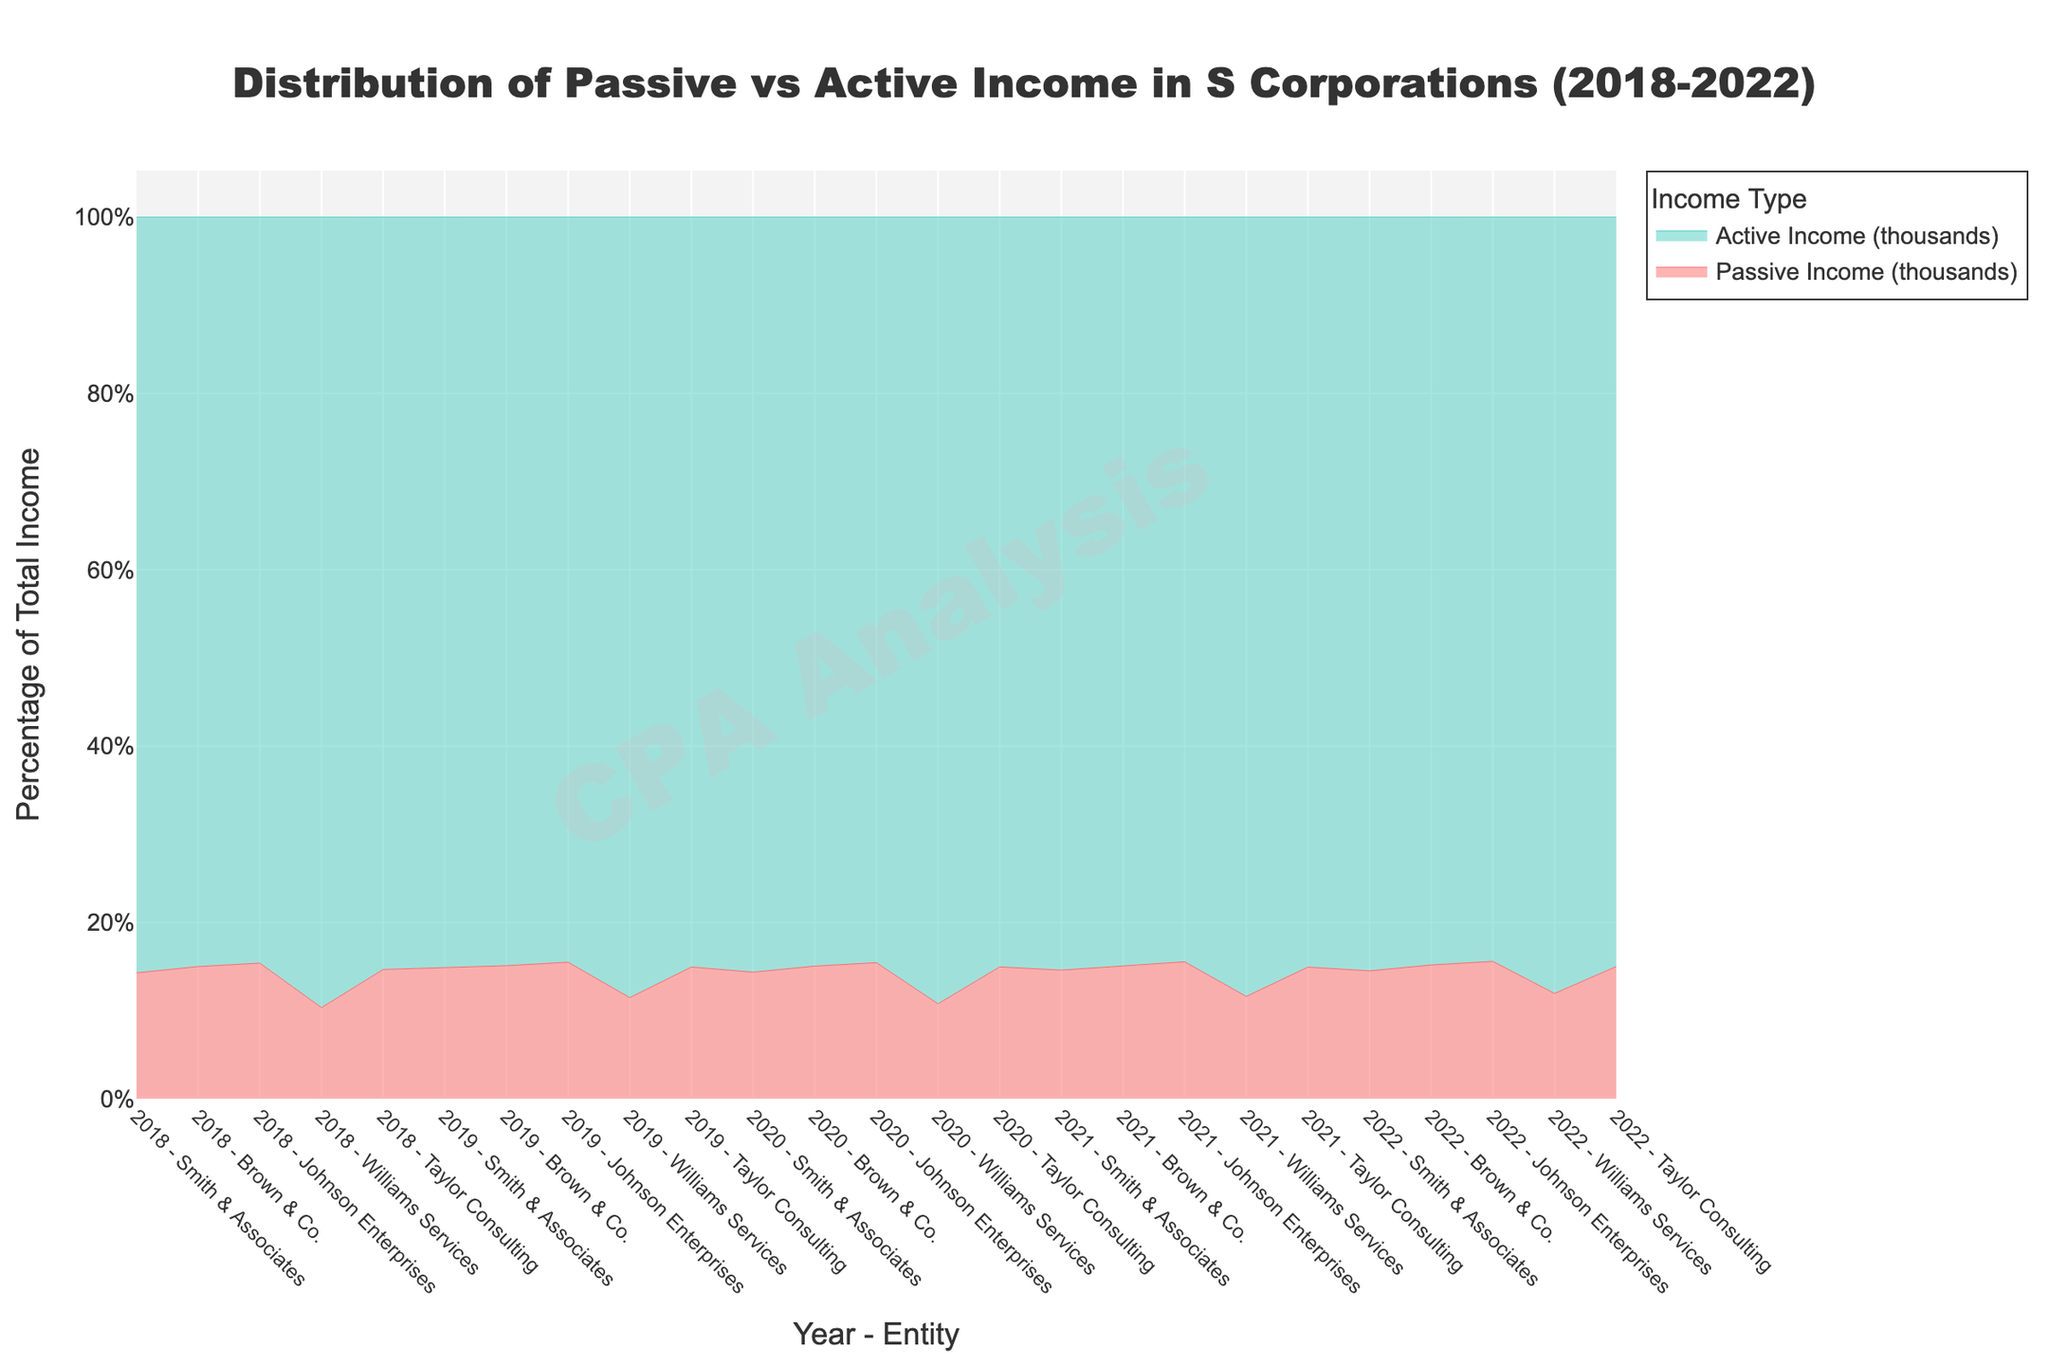What is the title of the figure? The title is usually placed at the top of the figure and is written in a large, bold font for emphasis. Here, the title is "Distribution of Passive vs Active Income in S Corporations (2018-2022)".
Answer: Distribution of Passive vs Active Income in S Corporations (2018-2022) Which income type, Passive Income or Active Income, has a higher value in 2022 for Brown & Co.? To answer this, look at the income values for 2022 corresponding to Brown & Co. in the graph. Compare the two values: Passive Income and Active Income. Active Income is higher than Passive Income in this case.
Answer: Active Income How does the percentage of Passive Income for Smith & Associates change from 2018 to 2022? Check the values of Passive Income and Active Income for Smith & Associates in each of those years, then calculate the percentage of Passive Income relative to the total income for those years. Compare these percentages from 2018 to 2022.
Answer: It increases In which year did Taylor Consulting have the highest Total Income (sum of Passive and Active Income)? Check the figure and add up the Passive and Active Incomes for Taylor Consulting for each year from 2018 to 2022. The year with the highest summed value will be the answer.
Answer: 2022 What color is used to represent Passive Income in the figure? Identify the color used for the Passive Income lines or areas in the chart. The custom colorscale indicates this, and visibly, Passive Income is represented by a distinct color different from Active Income.
Answer: Red Between 2018 and 2022, which entity has the most stable Passive Income? Examine the Passive Income values for all the entities across the years from 2018 to 2022. The entity whose Passive Income fluctuates the least in value is the one with the most stable Passive Income.
Answer: Johnson Enterprises Which entity experienced the greatest overall increase in Active Income from 2018 to 2022? Calculate the difference in Active Income from 2018 to 2022 for all entities. The entity with the largest positive difference has experienced the greatest overall increase in Active Income.
Answer: Brown & Co During which year did Williams Services have its lowest percentage of Passive Income relative to its Total Income? Calculate the percentage of Passive Income relative to Total Income for Williams Services for each year. The year with the lowest percentage is the answer.
Answer: 2018 